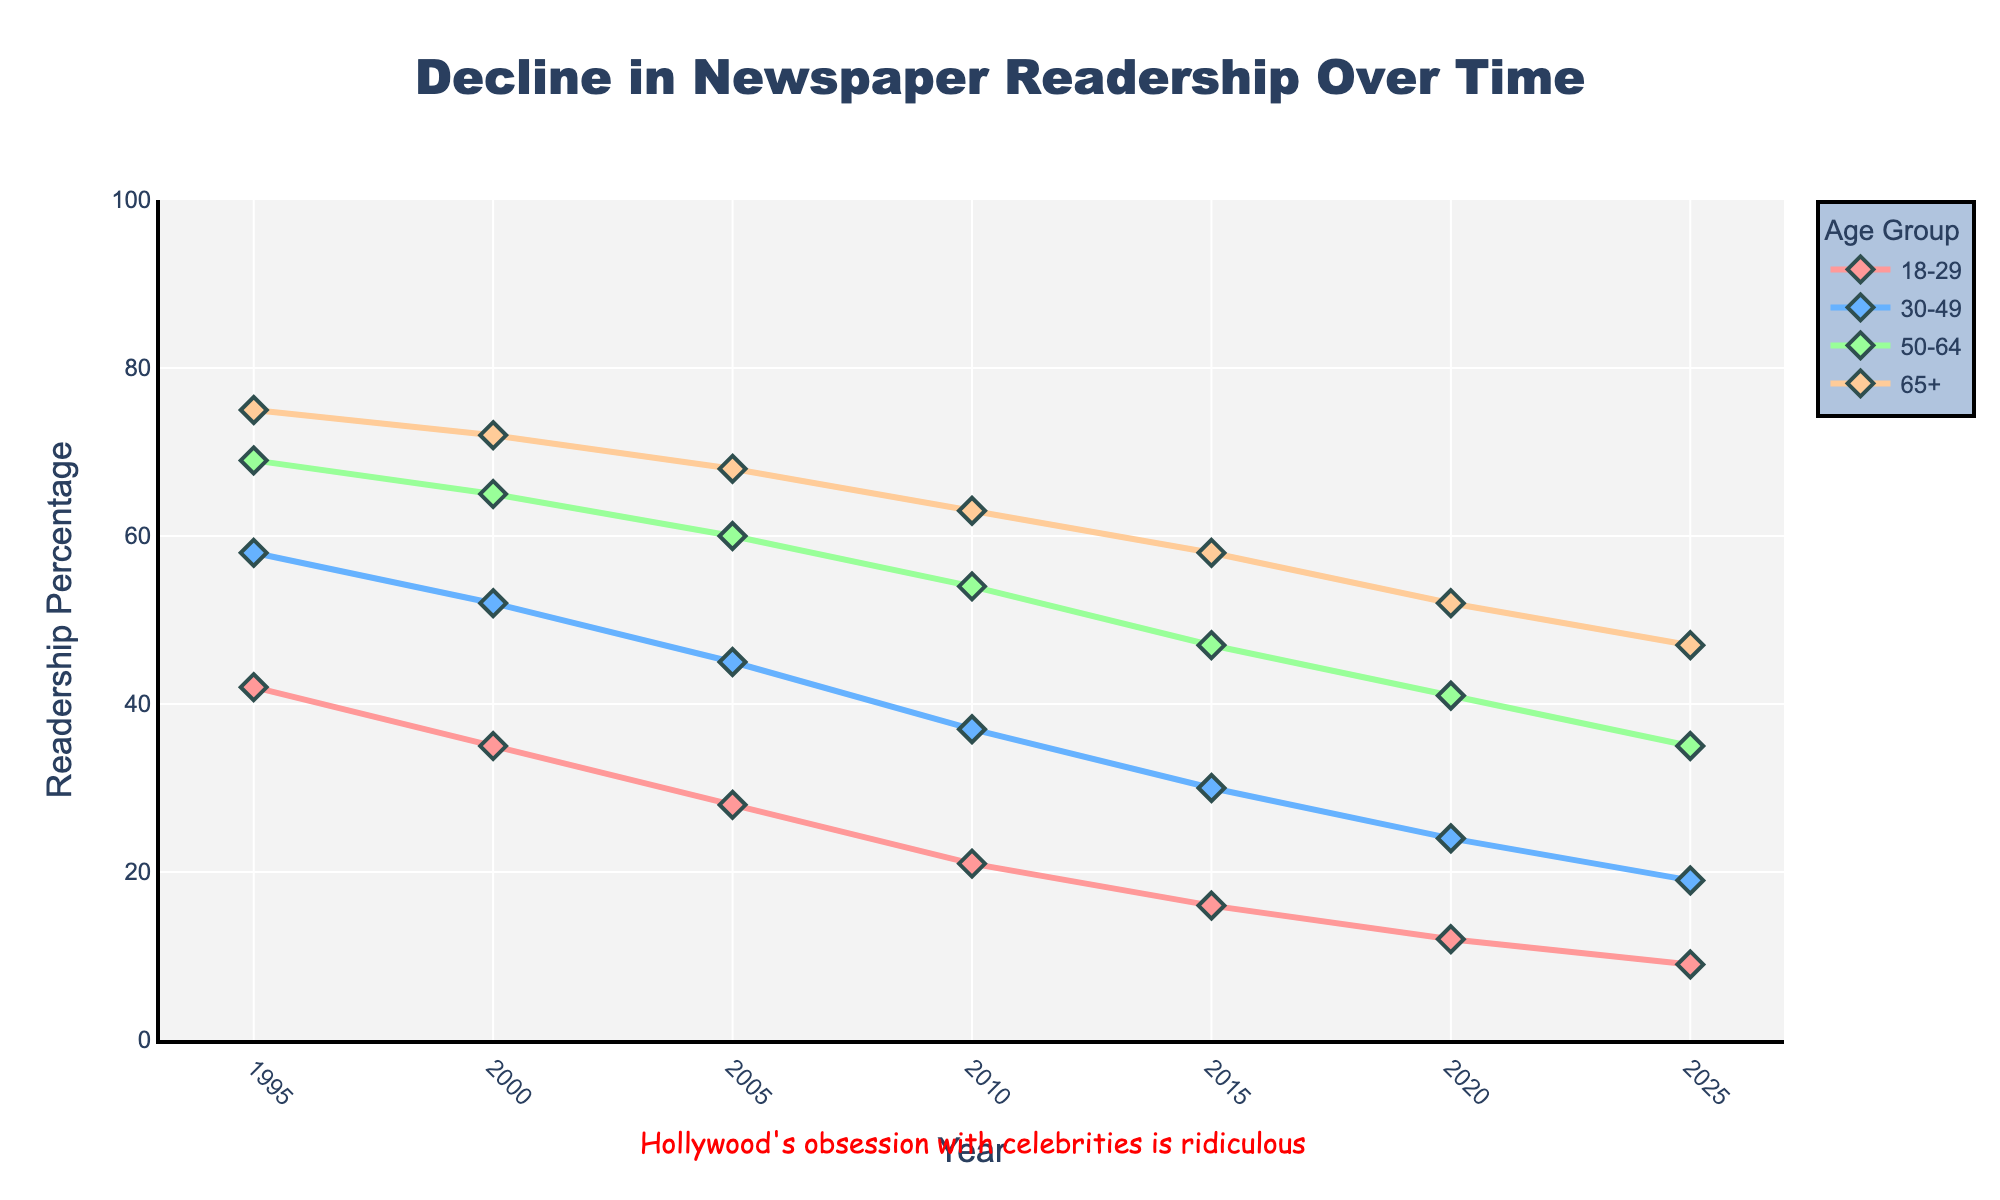Which age group had the highest newspaper readership in 1995? The chart shows that the 65+ age group had the highest percentage of readership at 75% in 1995.
Answer: 65+ By how much did the readership percentage for the 50-64 age group decrease from 1995 to 2025? Readership in 1995 for the 50-64 age group was 69%, and in 2025 it's 35%. The decrease is 69% - 35% = 34%.
Answer: 34% Which age group witnessed the smallest decrease in newspaper readership from 1995 to 2025? Comparing the decrease across all age groups: 18-29 (42% to 9% = 33%), 30-49 (58% to 19% = 39%), 50-64 (69% to 35% = 34%), 65+ (75% to 47% = 28%). The 65+ age group had the smallest decrease of 28%.
Answer: 65+ In which year did the 18-29 age group have a readership percentage equal to what the 65+ age group had in 2025? In 2025, the 65+ age group had a readership of 47%. The 18-29 age group also had around 47% readership in 2005.
Answer: 2005 Which age group's readership fell below 50% first, and in what year did it happen? The 18-29 age group's readership fell below 50% first. In 2000, it was at 35%, already below 50%.
Answer: 18-29, 2000 Compare the decline in readership for the 30-49 age group between 2000 and 2010. Did the rate of decline increase or decrease? Readership in 2000 for 30-49 was 52%, and by 2010, it was 37%. The decline from 2000 to 2010 is 52% - 37% = 15%. In the previous period, 1995 to 2000, the decline was 58% - 52% = 6%. The rate of decline increased from 6% to 15%.
Answer: Increased What is the average newspaper readership percentage for the 65+ age group across all the years shown? Summing the percentages for the 65+ age group (75 + 72 + 68 + 63 + 58 + 52 + 47) gives 435%. Dividing by the number of data points (7 years) gives an average of 435 / 7 ≈ 62.14%.
Answer: 62.14% Which two age groups had the largest and smallest overall percentage decline in readership from 1995 to 2020? Largest decline: 30-49 (58% to 24% = 34%). Smallest decline: 65+ (75% to 52% = 23%). So, the 30-49 age group had the largest decline and the 65+ had the smallest.
Answer: 30-49, 65+ How much higher was the newspaper readership percentage for the 65+ age group compared to the 18-29 age group in 2020? In 2020, the 65+ age group had a readership of 52%, and the 18-29 had 12%. The difference is 52% - 12% = 40%.
Answer: 40% 